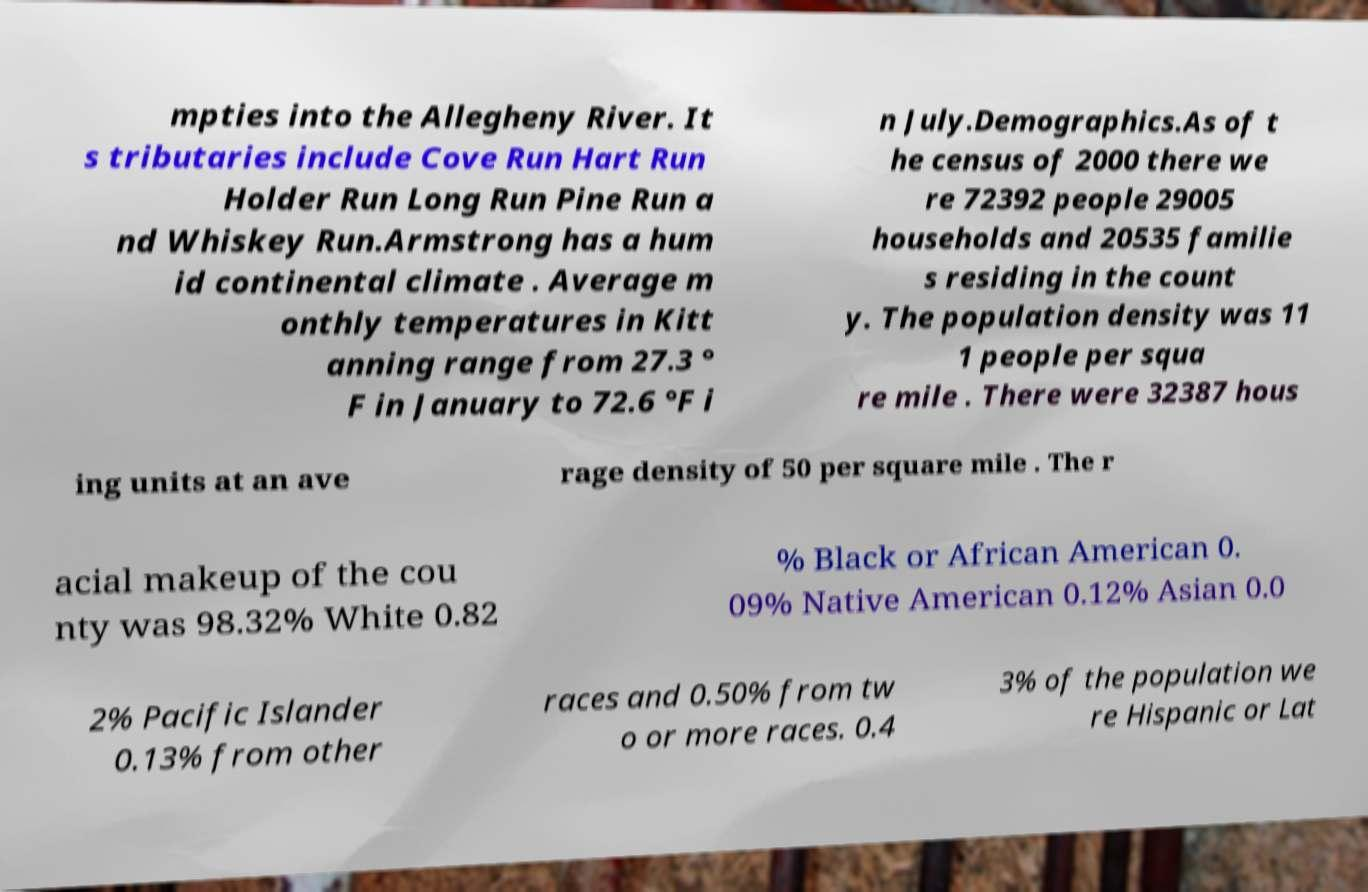For documentation purposes, I need the text within this image transcribed. Could you provide that? mpties into the Allegheny River. It s tributaries include Cove Run Hart Run Holder Run Long Run Pine Run a nd Whiskey Run.Armstrong has a hum id continental climate . Average m onthly temperatures in Kitt anning range from 27.3 ° F in January to 72.6 °F i n July.Demographics.As of t he census of 2000 there we re 72392 people 29005 households and 20535 familie s residing in the count y. The population density was 11 1 people per squa re mile . There were 32387 hous ing units at an ave rage density of 50 per square mile . The r acial makeup of the cou nty was 98.32% White 0.82 % Black or African American 0. 09% Native American 0.12% Asian 0.0 2% Pacific Islander 0.13% from other races and 0.50% from tw o or more races. 0.4 3% of the population we re Hispanic or Lat 